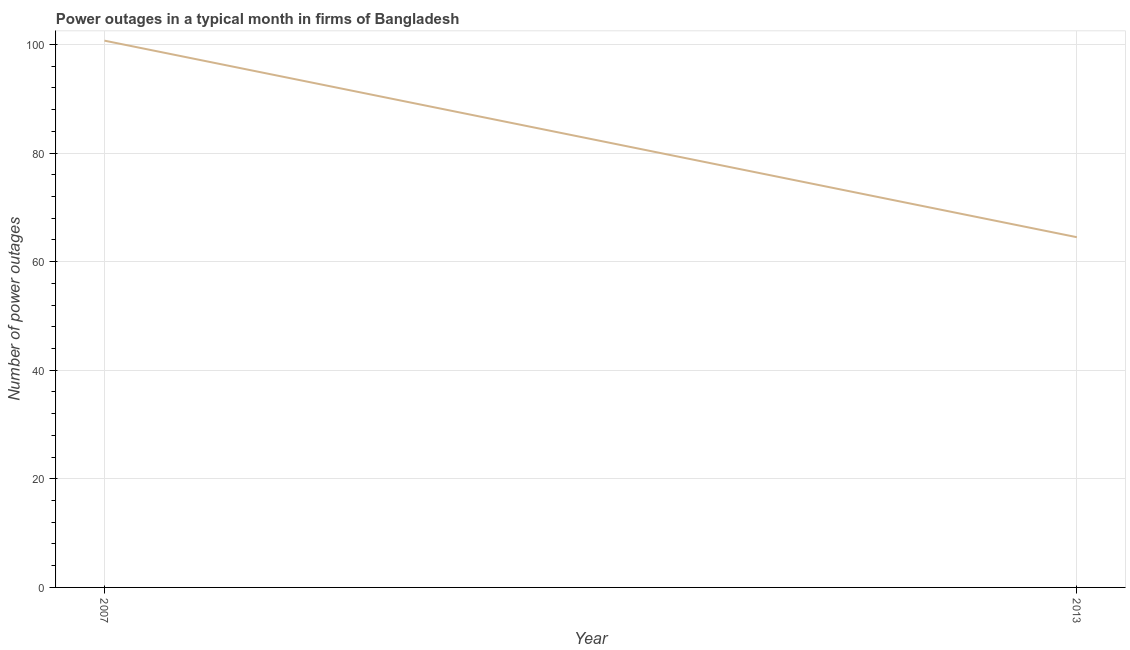What is the number of power outages in 2007?
Keep it short and to the point. 100.7. Across all years, what is the maximum number of power outages?
Ensure brevity in your answer.  100.7. Across all years, what is the minimum number of power outages?
Give a very brief answer. 64.5. What is the sum of the number of power outages?
Your answer should be very brief. 165.2. What is the difference between the number of power outages in 2007 and 2013?
Make the answer very short. 36.2. What is the average number of power outages per year?
Your answer should be compact. 82.6. What is the median number of power outages?
Keep it short and to the point. 82.6. In how many years, is the number of power outages greater than 52 ?
Keep it short and to the point. 2. Do a majority of the years between 2013 and 2007 (inclusive) have number of power outages greater than 36 ?
Provide a short and direct response. No. What is the ratio of the number of power outages in 2007 to that in 2013?
Your response must be concise. 1.56. Does the number of power outages monotonically increase over the years?
Your answer should be very brief. No. How many lines are there?
Your response must be concise. 1. How many years are there in the graph?
Make the answer very short. 2. What is the difference between two consecutive major ticks on the Y-axis?
Offer a terse response. 20. Are the values on the major ticks of Y-axis written in scientific E-notation?
Your response must be concise. No. Does the graph contain any zero values?
Ensure brevity in your answer.  No. What is the title of the graph?
Keep it short and to the point. Power outages in a typical month in firms of Bangladesh. What is the label or title of the X-axis?
Provide a short and direct response. Year. What is the label or title of the Y-axis?
Your response must be concise. Number of power outages. What is the Number of power outages in 2007?
Keep it short and to the point. 100.7. What is the Number of power outages in 2013?
Offer a very short reply. 64.5. What is the difference between the Number of power outages in 2007 and 2013?
Your answer should be compact. 36.2. What is the ratio of the Number of power outages in 2007 to that in 2013?
Ensure brevity in your answer.  1.56. 